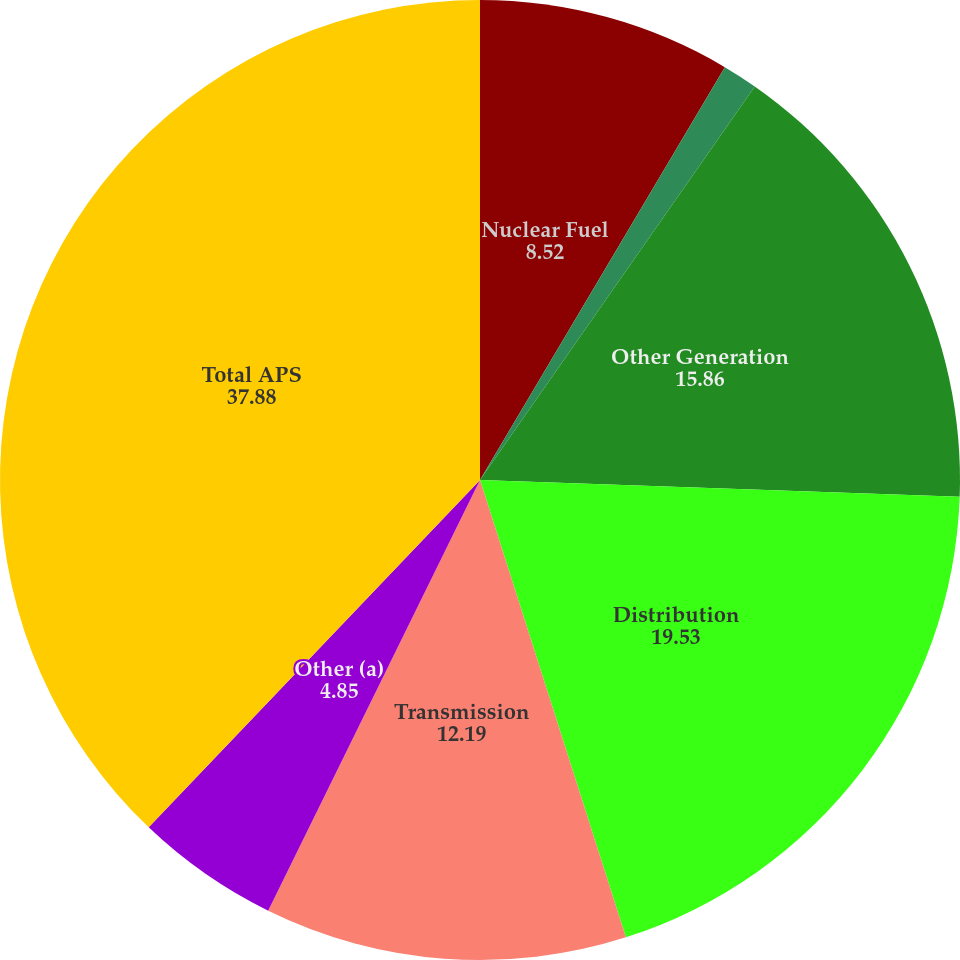Convert chart to OTSL. <chart><loc_0><loc_0><loc_500><loc_500><pie_chart><fcel>Nuclear Fuel<fcel>Environmental<fcel>Other Generation<fcel>Distribution<fcel>Transmission<fcel>Other (a)<fcel>Total APS<nl><fcel>8.52%<fcel>1.18%<fcel>15.86%<fcel>19.53%<fcel>12.19%<fcel>4.85%<fcel>37.88%<nl></chart> 